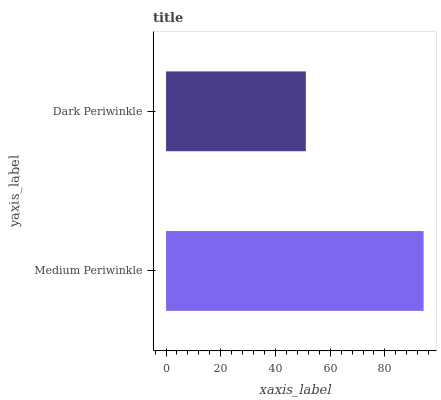Is Dark Periwinkle the minimum?
Answer yes or no. Yes. Is Medium Periwinkle the maximum?
Answer yes or no. Yes. Is Dark Periwinkle the maximum?
Answer yes or no. No. Is Medium Periwinkle greater than Dark Periwinkle?
Answer yes or no. Yes. Is Dark Periwinkle less than Medium Periwinkle?
Answer yes or no. Yes. Is Dark Periwinkle greater than Medium Periwinkle?
Answer yes or no. No. Is Medium Periwinkle less than Dark Periwinkle?
Answer yes or no. No. Is Medium Periwinkle the high median?
Answer yes or no. Yes. Is Dark Periwinkle the low median?
Answer yes or no. Yes. Is Dark Periwinkle the high median?
Answer yes or no. No. Is Medium Periwinkle the low median?
Answer yes or no. No. 